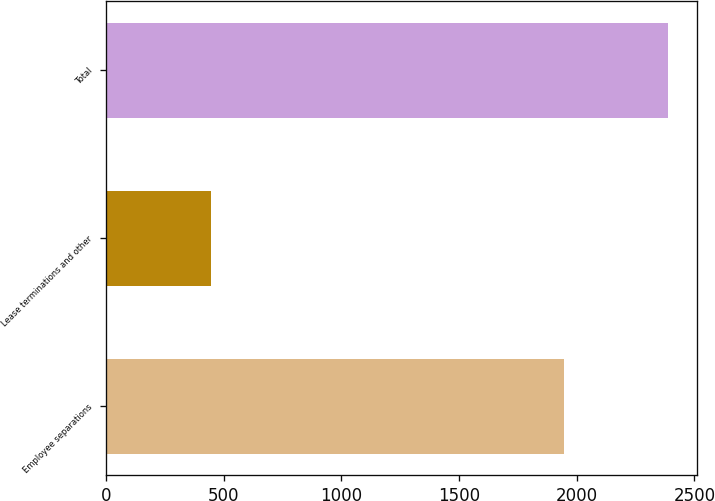<chart> <loc_0><loc_0><loc_500><loc_500><bar_chart><fcel>Employee separations<fcel>Lease terminations and other<fcel>Total<nl><fcel>1945<fcel>445<fcel>2390<nl></chart> 